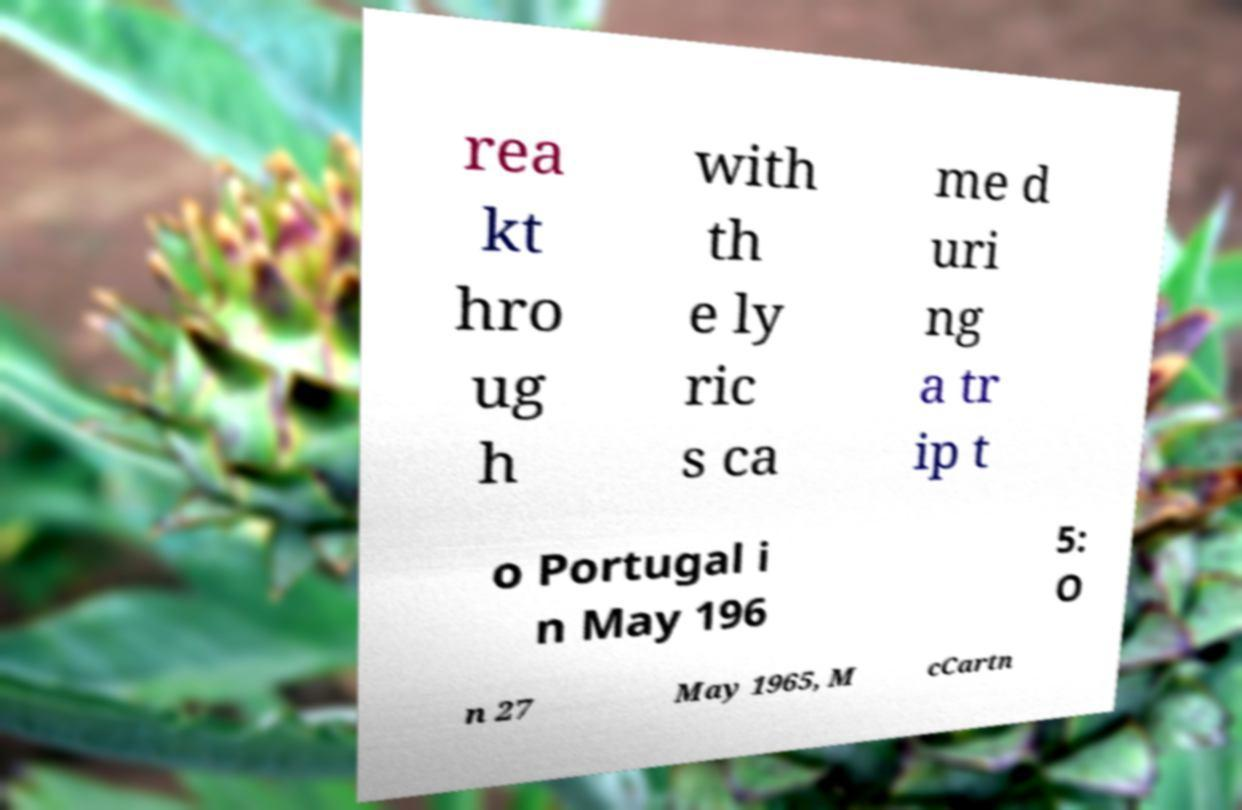Could you extract and type out the text from this image? rea kt hro ug h with th e ly ric s ca me d uri ng a tr ip t o Portugal i n May 196 5: O n 27 May 1965, M cCartn 